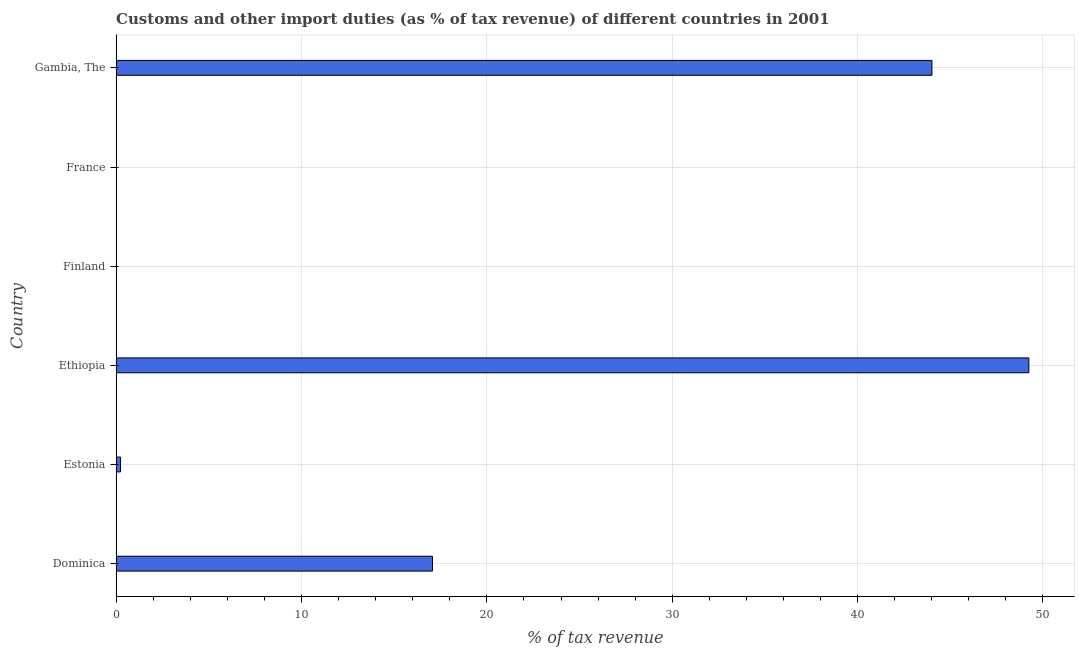Does the graph contain grids?
Provide a short and direct response. Yes. What is the title of the graph?
Offer a very short reply. Customs and other import duties (as % of tax revenue) of different countries in 2001. What is the label or title of the X-axis?
Keep it short and to the point. % of tax revenue. What is the label or title of the Y-axis?
Give a very brief answer. Country. Across all countries, what is the maximum customs and other import duties?
Give a very brief answer. 49.24. Across all countries, what is the minimum customs and other import duties?
Give a very brief answer. 0. In which country was the customs and other import duties maximum?
Offer a very short reply. Ethiopia. What is the sum of the customs and other import duties?
Provide a succinct answer. 110.56. What is the difference between the customs and other import duties in Dominica and Ethiopia?
Offer a terse response. -32.17. What is the average customs and other import duties per country?
Keep it short and to the point. 18.43. What is the median customs and other import duties?
Provide a short and direct response. 8.65. In how many countries, is the customs and other import duties greater than 18 %?
Your answer should be compact. 2. What is the ratio of the customs and other import duties in Dominica to that in France?
Give a very brief answer. 8378.35. Is the customs and other import duties in Estonia less than that in Gambia, The?
Provide a short and direct response. Yes. What is the difference between the highest and the second highest customs and other import duties?
Provide a succinct answer. 5.23. Is the sum of the customs and other import duties in Dominica and France greater than the maximum customs and other import duties across all countries?
Offer a very short reply. No. What is the difference between the highest and the lowest customs and other import duties?
Keep it short and to the point. 49.24. How many bars are there?
Your response must be concise. 5. Are all the bars in the graph horizontal?
Your response must be concise. Yes. How many countries are there in the graph?
Provide a short and direct response. 6. What is the difference between two consecutive major ticks on the X-axis?
Offer a very short reply. 10. Are the values on the major ticks of X-axis written in scientific E-notation?
Ensure brevity in your answer.  No. What is the % of tax revenue of Dominica?
Offer a terse response. 17.07. What is the % of tax revenue in Estonia?
Make the answer very short. 0.24. What is the % of tax revenue of Ethiopia?
Offer a very short reply. 49.24. What is the % of tax revenue of Finland?
Offer a very short reply. 0. What is the % of tax revenue of France?
Offer a very short reply. 0. What is the % of tax revenue in Gambia, The?
Keep it short and to the point. 44.01. What is the difference between the % of tax revenue in Dominica and Estonia?
Offer a terse response. 16.83. What is the difference between the % of tax revenue in Dominica and Ethiopia?
Your response must be concise. -32.17. What is the difference between the % of tax revenue in Dominica and France?
Provide a succinct answer. 17.06. What is the difference between the % of tax revenue in Dominica and Gambia, The?
Your answer should be compact. -26.94. What is the difference between the % of tax revenue in Estonia and Ethiopia?
Your answer should be very brief. -49. What is the difference between the % of tax revenue in Estonia and France?
Provide a short and direct response. 0.24. What is the difference between the % of tax revenue in Estonia and Gambia, The?
Keep it short and to the point. -43.77. What is the difference between the % of tax revenue in Ethiopia and France?
Your answer should be compact. 49.24. What is the difference between the % of tax revenue in Ethiopia and Gambia, The?
Provide a short and direct response. 5.23. What is the difference between the % of tax revenue in France and Gambia, The?
Give a very brief answer. -44.01. What is the ratio of the % of tax revenue in Dominica to that in Estonia?
Keep it short and to the point. 71.96. What is the ratio of the % of tax revenue in Dominica to that in Ethiopia?
Your answer should be compact. 0.35. What is the ratio of the % of tax revenue in Dominica to that in France?
Your answer should be compact. 8378.35. What is the ratio of the % of tax revenue in Dominica to that in Gambia, The?
Keep it short and to the point. 0.39. What is the ratio of the % of tax revenue in Estonia to that in Ethiopia?
Offer a very short reply. 0.01. What is the ratio of the % of tax revenue in Estonia to that in France?
Give a very brief answer. 116.44. What is the ratio of the % of tax revenue in Estonia to that in Gambia, The?
Give a very brief answer. 0.01. What is the ratio of the % of tax revenue in Ethiopia to that in France?
Your response must be concise. 2.42e+04. What is the ratio of the % of tax revenue in Ethiopia to that in Gambia, The?
Provide a succinct answer. 1.12. What is the ratio of the % of tax revenue in France to that in Gambia, The?
Make the answer very short. 0. 